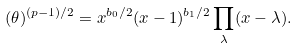Convert formula to latex. <formula><loc_0><loc_0><loc_500><loc_500>( \theta ) ^ { { ( p - 1 ) } / { 2 } } = x ^ { { b _ { 0 } } / { 2 } } ( x - 1 ) ^ { { b _ { 1 } } / { 2 } } \prod _ { \lambda } ( x - \lambda ) .</formula> 